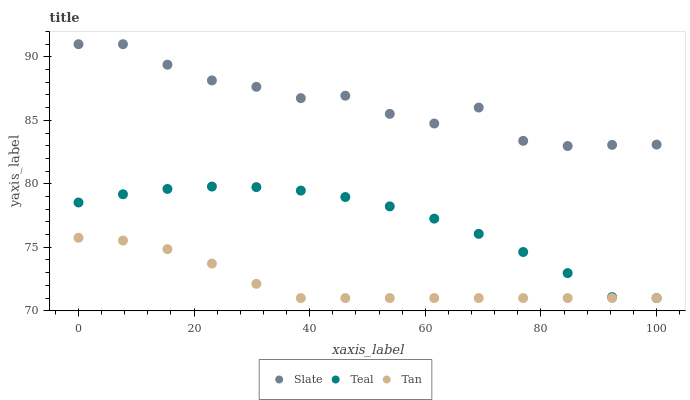Does Tan have the minimum area under the curve?
Answer yes or no. Yes. Does Slate have the maximum area under the curve?
Answer yes or no. Yes. Does Teal have the minimum area under the curve?
Answer yes or no. No. Does Teal have the maximum area under the curve?
Answer yes or no. No. Is Tan the smoothest?
Answer yes or no. Yes. Is Slate the roughest?
Answer yes or no. Yes. Is Teal the smoothest?
Answer yes or no. No. Is Teal the roughest?
Answer yes or no. No. Does Tan have the lowest value?
Answer yes or no. Yes. Does Slate have the highest value?
Answer yes or no. Yes. Does Teal have the highest value?
Answer yes or no. No. Is Tan less than Slate?
Answer yes or no. Yes. Is Slate greater than Teal?
Answer yes or no. Yes. Does Teal intersect Tan?
Answer yes or no. Yes. Is Teal less than Tan?
Answer yes or no. No. Is Teal greater than Tan?
Answer yes or no. No. Does Tan intersect Slate?
Answer yes or no. No. 